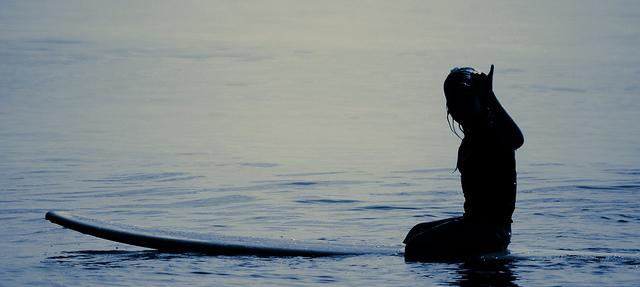Is the person in the middle of the sea?
Be succinct. No. What is he on?
Short answer required. Surfboard. Is this night?
Concise answer only. No. Is the woman's hair tied up or down?
Write a very short answer. Down. 